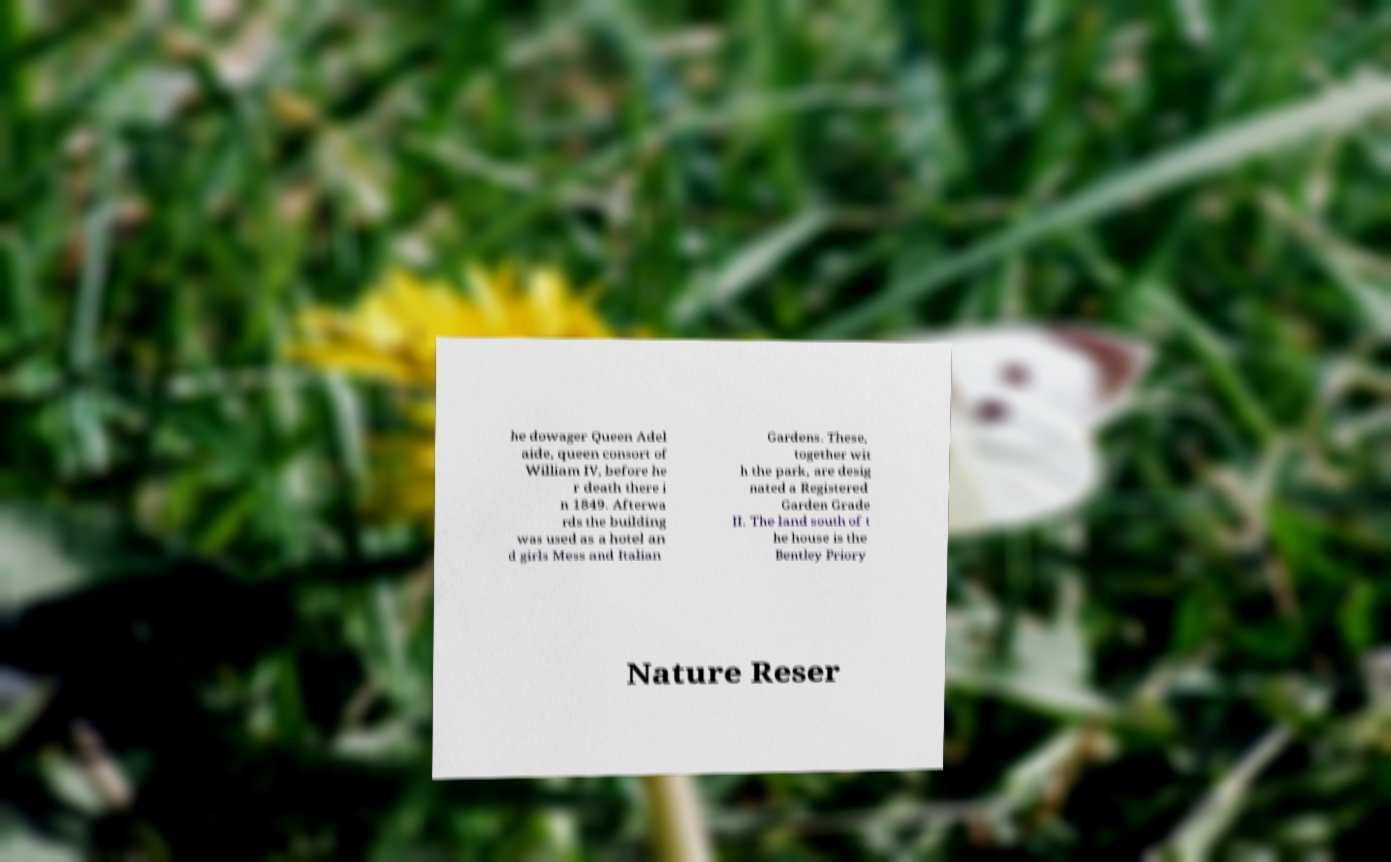For documentation purposes, I need the text within this image transcribed. Could you provide that? he dowager Queen Adel aide, queen consort of William IV, before he r death there i n 1849. Afterwa rds the building was used as a hotel an d girls Mess and Italian Gardens. These, together wit h the park, are desig nated a Registered Garden Grade II. The land south of t he house is the Bentley Priory Nature Reser 